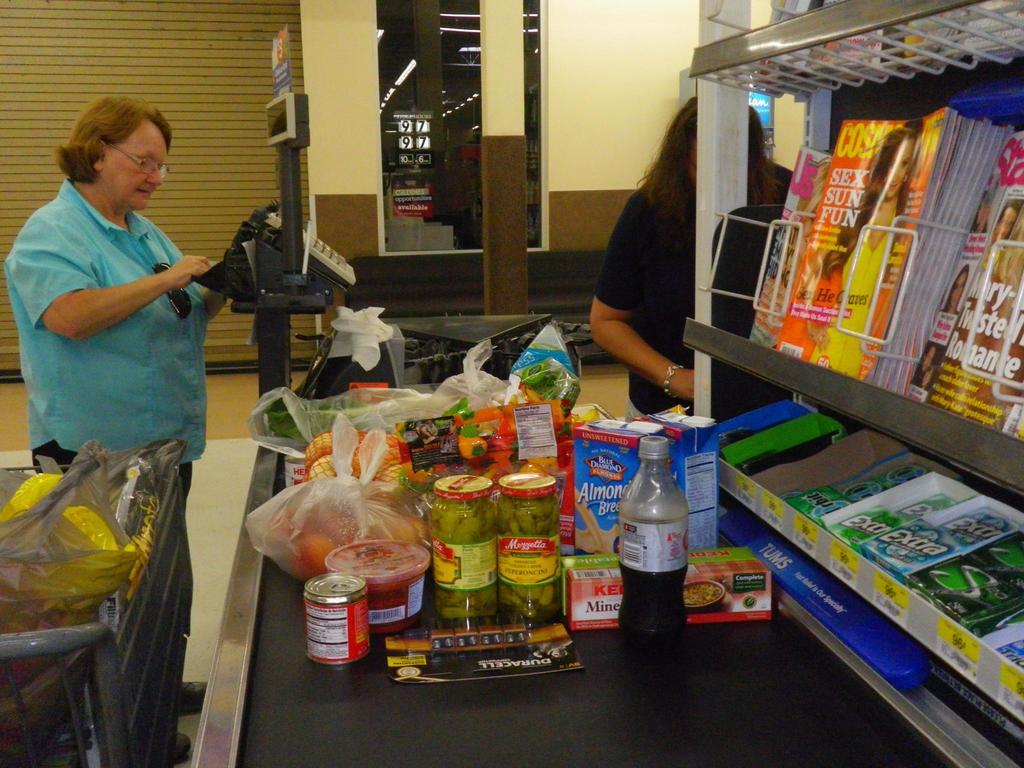What is the brand name of the product in the blue carton?
Ensure brevity in your answer.  Blue diamond. What brand of batteries are on the belt?
Your answer should be compact. Duracell. 